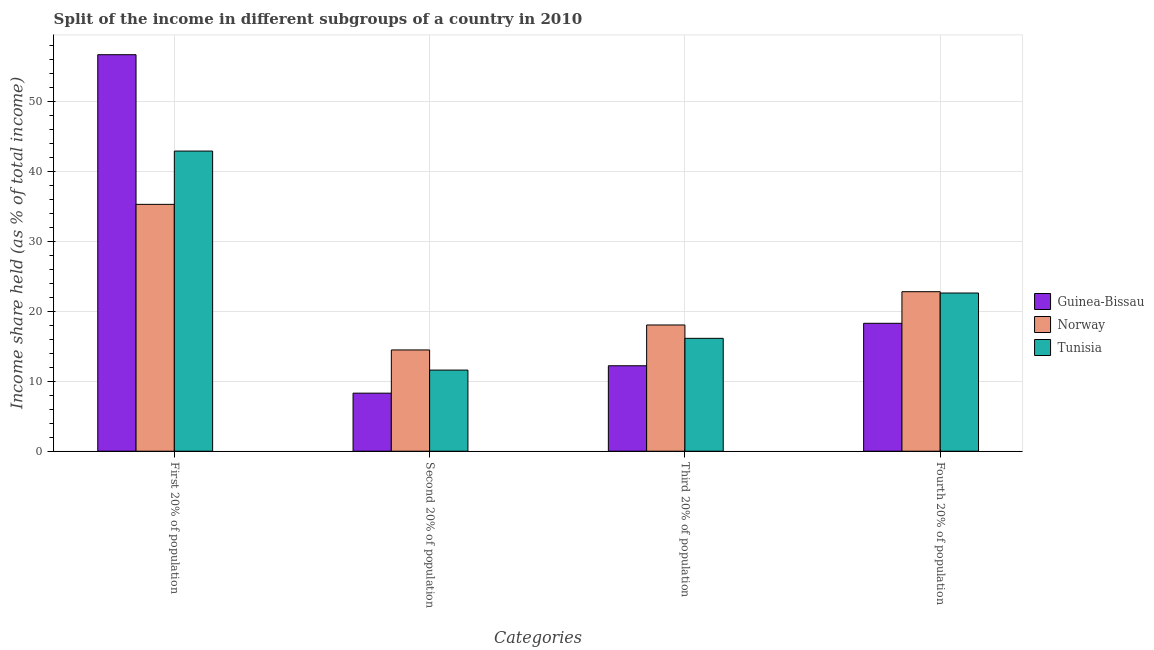Are the number of bars per tick equal to the number of legend labels?
Provide a succinct answer. Yes. How many bars are there on the 2nd tick from the left?
Offer a terse response. 3. What is the label of the 3rd group of bars from the left?
Provide a short and direct response. Third 20% of population. What is the share of the income held by fourth 20% of the population in Norway?
Ensure brevity in your answer.  22.81. Across all countries, what is the maximum share of the income held by second 20% of the population?
Make the answer very short. 14.48. Across all countries, what is the minimum share of the income held by second 20% of the population?
Ensure brevity in your answer.  8.3. In which country was the share of the income held by fourth 20% of the population minimum?
Your response must be concise. Guinea-Bissau. What is the total share of the income held by second 20% of the population in the graph?
Your response must be concise. 34.38. What is the difference between the share of the income held by fourth 20% of the population in Guinea-Bissau and that in Tunisia?
Make the answer very short. -4.33. What is the difference between the share of the income held by second 20% of the population in Guinea-Bissau and the share of the income held by first 20% of the population in Norway?
Keep it short and to the point. -27. What is the average share of the income held by second 20% of the population per country?
Ensure brevity in your answer.  11.46. What is the difference between the share of the income held by first 20% of the population and share of the income held by second 20% of the population in Guinea-Bissau?
Your answer should be very brief. 48.4. In how many countries, is the share of the income held by third 20% of the population greater than 20 %?
Give a very brief answer. 0. What is the ratio of the share of the income held by fourth 20% of the population in Norway to that in Guinea-Bissau?
Offer a very short reply. 1.25. Is the share of the income held by third 20% of the population in Norway less than that in Tunisia?
Ensure brevity in your answer.  No. What is the difference between the highest and the second highest share of the income held by fourth 20% of the population?
Your answer should be compact. 0.19. What is the difference between the highest and the lowest share of the income held by first 20% of the population?
Make the answer very short. 21.4. Is the sum of the share of the income held by second 20% of the population in Tunisia and Guinea-Bissau greater than the maximum share of the income held by fourth 20% of the population across all countries?
Make the answer very short. No. Is it the case that in every country, the sum of the share of the income held by fourth 20% of the population and share of the income held by second 20% of the population is greater than the sum of share of the income held by first 20% of the population and share of the income held by third 20% of the population?
Keep it short and to the point. No. What does the 2nd bar from the left in Second 20% of population represents?
Your answer should be compact. Norway. What does the 1st bar from the right in Third 20% of population represents?
Your answer should be very brief. Tunisia. Is it the case that in every country, the sum of the share of the income held by first 20% of the population and share of the income held by second 20% of the population is greater than the share of the income held by third 20% of the population?
Your answer should be very brief. Yes. How many countries are there in the graph?
Keep it short and to the point. 3. Does the graph contain grids?
Provide a short and direct response. Yes. Where does the legend appear in the graph?
Ensure brevity in your answer.  Center right. How are the legend labels stacked?
Your answer should be very brief. Vertical. What is the title of the graph?
Keep it short and to the point. Split of the income in different subgroups of a country in 2010. What is the label or title of the X-axis?
Your response must be concise. Categories. What is the label or title of the Y-axis?
Give a very brief answer. Income share held (as % of total income). What is the Income share held (as % of total income) of Guinea-Bissau in First 20% of population?
Offer a terse response. 56.7. What is the Income share held (as % of total income) of Norway in First 20% of population?
Provide a succinct answer. 35.3. What is the Income share held (as % of total income) of Tunisia in First 20% of population?
Your response must be concise. 42.92. What is the Income share held (as % of total income) of Norway in Second 20% of population?
Ensure brevity in your answer.  14.48. What is the Income share held (as % of total income) in Tunisia in Second 20% of population?
Your answer should be compact. 11.6. What is the Income share held (as % of total income) in Guinea-Bissau in Third 20% of population?
Keep it short and to the point. 12.22. What is the Income share held (as % of total income) of Norway in Third 20% of population?
Provide a succinct answer. 18.05. What is the Income share held (as % of total income) in Tunisia in Third 20% of population?
Offer a terse response. 16.14. What is the Income share held (as % of total income) of Guinea-Bissau in Fourth 20% of population?
Offer a terse response. 18.29. What is the Income share held (as % of total income) in Norway in Fourth 20% of population?
Keep it short and to the point. 22.81. What is the Income share held (as % of total income) in Tunisia in Fourth 20% of population?
Your answer should be very brief. 22.62. Across all Categories, what is the maximum Income share held (as % of total income) of Guinea-Bissau?
Offer a terse response. 56.7. Across all Categories, what is the maximum Income share held (as % of total income) of Norway?
Your response must be concise. 35.3. Across all Categories, what is the maximum Income share held (as % of total income) in Tunisia?
Keep it short and to the point. 42.92. Across all Categories, what is the minimum Income share held (as % of total income) of Guinea-Bissau?
Provide a succinct answer. 8.3. Across all Categories, what is the minimum Income share held (as % of total income) of Norway?
Your answer should be compact. 14.48. What is the total Income share held (as % of total income) of Guinea-Bissau in the graph?
Provide a succinct answer. 95.51. What is the total Income share held (as % of total income) in Norway in the graph?
Offer a very short reply. 90.64. What is the total Income share held (as % of total income) in Tunisia in the graph?
Offer a terse response. 93.28. What is the difference between the Income share held (as % of total income) in Guinea-Bissau in First 20% of population and that in Second 20% of population?
Make the answer very short. 48.4. What is the difference between the Income share held (as % of total income) in Norway in First 20% of population and that in Second 20% of population?
Offer a very short reply. 20.82. What is the difference between the Income share held (as % of total income) in Tunisia in First 20% of population and that in Second 20% of population?
Offer a terse response. 31.32. What is the difference between the Income share held (as % of total income) of Guinea-Bissau in First 20% of population and that in Third 20% of population?
Offer a very short reply. 44.48. What is the difference between the Income share held (as % of total income) in Norway in First 20% of population and that in Third 20% of population?
Your answer should be very brief. 17.25. What is the difference between the Income share held (as % of total income) in Tunisia in First 20% of population and that in Third 20% of population?
Your response must be concise. 26.78. What is the difference between the Income share held (as % of total income) in Guinea-Bissau in First 20% of population and that in Fourth 20% of population?
Provide a succinct answer. 38.41. What is the difference between the Income share held (as % of total income) of Norway in First 20% of population and that in Fourth 20% of population?
Your answer should be compact. 12.49. What is the difference between the Income share held (as % of total income) of Tunisia in First 20% of population and that in Fourth 20% of population?
Make the answer very short. 20.3. What is the difference between the Income share held (as % of total income) of Guinea-Bissau in Second 20% of population and that in Third 20% of population?
Provide a short and direct response. -3.92. What is the difference between the Income share held (as % of total income) in Norway in Second 20% of population and that in Third 20% of population?
Provide a succinct answer. -3.57. What is the difference between the Income share held (as % of total income) in Tunisia in Second 20% of population and that in Third 20% of population?
Offer a very short reply. -4.54. What is the difference between the Income share held (as % of total income) in Guinea-Bissau in Second 20% of population and that in Fourth 20% of population?
Your answer should be compact. -9.99. What is the difference between the Income share held (as % of total income) in Norway in Second 20% of population and that in Fourth 20% of population?
Provide a short and direct response. -8.33. What is the difference between the Income share held (as % of total income) of Tunisia in Second 20% of population and that in Fourth 20% of population?
Your answer should be compact. -11.02. What is the difference between the Income share held (as % of total income) in Guinea-Bissau in Third 20% of population and that in Fourth 20% of population?
Give a very brief answer. -6.07. What is the difference between the Income share held (as % of total income) of Norway in Third 20% of population and that in Fourth 20% of population?
Your response must be concise. -4.76. What is the difference between the Income share held (as % of total income) of Tunisia in Third 20% of population and that in Fourth 20% of population?
Your answer should be compact. -6.48. What is the difference between the Income share held (as % of total income) of Guinea-Bissau in First 20% of population and the Income share held (as % of total income) of Norway in Second 20% of population?
Keep it short and to the point. 42.22. What is the difference between the Income share held (as % of total income) of Guinea-Bissau in First 20% of population and the Income share held (as % of total income) of Tunisia in Second 20% of population?
Ensure brevity in your answer.  45.1. What is the difference between the Income share held (as % of total income) of Norway in First 20% of population and the Income share held (as % of total income) of Tunisia in Second 20% of population?
Keep it short and to the point. 23.7. What is the difference between the Income share held (as % of total income) of Guinea-Bissau in First 20% of population and the Income share held (as % of total income) of Norway in Third 20% of population?
Your answer should be very brief. 38.65. What is the difference between the Income share held (as % of total income) of Guinea-Bissau in First 20% of population and the Income share held (as % of total income) of Tunisia in Third 20% of population?
Your answer should be compact. 40.56. What is the difference between the Income share held (as % of total income) of Norway in First 20% of population and the Income share held (as % of total income) of Tunisia in Third 20% of population?
Make the answer very short. 19.16. What is the difference between the Income share held (as % of total income) of Guinea-Bissau in First 20% of population and the Income share held (as % of total income) of Norway in Fourth 20% of population?
Make the answer very short. 33.89. What is the difference between the Income share held (as % of total income) in Guinea-Bissau in First 20% of population and the Income share held (as % of total income) in Tunisia in Fourth 20% of population?
Your answer should be compact. 34.08. What is the difference between the Income share held (as % of total income) of Norway in First 20% of population and the Income share held (as % of total income) of Tunisia in Fourth 20% of population?
Offer a terse response. 12.68. What is the difference between the Income share held (as % of total income) of Guinea-Bissau in Second 20% of population and the Income share held (as % of total income) of Norway in Third 20% of population?
Your answer should be compact. -9.75. What is the difference between the Income share held (as % of total income) of Guinea-Bissau in Second 20% of population and the Income share held (as % of total income) of Tunisia in Third 20% of population?
Provide a short and direct response. -7.84. What is the difference between the Income share held (as % of total income) of Norway in Second 20% of population and the Income share held (as % of total income) of Tunisia in Third 20% of population?
Ensure brevity in your answer.  -1.66. What is the difference between the Income share held (as % of total income) in Guinea-Bissau in Second 20% of population and the Income share held (as % of total income) in Norway in Fourth 20% of population?
Offer a very short reply. -14.51. What is the difference between the Income share held (as % of total income) in Guinea-Bissau in Second 20% of population and the Income share held (as % of total income) in Tunisia in Fourth 20% of population?
Provide a short and direct response. -14.32. What is the difference between the Income share held (as % of total income) in Norway in Second 20% of population and the Income share held (as % of total income) in Tunisia in Fourth 20% of population?
Your answer should be compact. -8.14. What is the difference between the Income share held (as % of total income) of Guinea-Bissau in Third 20% of population and the Income share held (as % of total income) of Norway in Fourth 20% of population?
Provide a short and direct response. -10.59. What is the difference between the Income share held (as % of total income) of Guinea-Bissau in Third 20% of population and the Income share held (as % of total income) of Tunisia in Fourth 20% of population?
Provide a succinct answer. -10.4. What is the difference between the Income share held (as % of total income) in Norway in Third 20% of population and the Income share held (as % of total income) in Tunisia in Fourth 20% of population?
Offer a terse response. -4.57. What is the average Income share held (as % of total income) of Guinea-Bissau per Categories?
Your response must be concise. 23.88. What is the average Income share held (as % of total income) in Norway per Categories?
Make the answer very short. 22.66. What is the average Income share held (as % of total income) in Tunisia per Categories?
Your response must be concise. 23.32. What is the difference between the Income share held (as % of total income) of Guinea-Bissau and Income share held (as % of total income) of Norway in First 20% of population?
Keep it short and to the point. 21.4. What is the difference between the Income share held (as % of total income) in Guinea-Bissau and Income share held (as % of total income) in Tunisia in First 20% of population?
Your answer should be very brief. 13.78. What is the difference between the Income share held (as % of total income) in Norway and Income share held (as % of total income) in Tunisia in First 20% of population?
Offer a very short reply. -7.62. What is the difference between the Income share held (as % of total income) in Guinea-Bissau and Income share held (as % of total income) in Norway in Second 20% of population?
Make the answer very short. -6.18. What is the difference between the Income share held (as % of total income) of Norway and Income share held (as % of total income) of Tunisia in Second 20% of population?
Keep it short and to the point. 2.88. What is the difference between the Income share held (as % of total income) of Guinea-Bissau and Income share held (as % of total income) of Norway in Third 20% of population?
Offer a terse response. -5.83. What is the difference between the Income share held (as % of total income) in Guinea-Bissau and Income share held (as % of total income) in Tunisia in Third 20% of population?
Your response must be concise. -3.92. What is the difference between the Income share held (as % of total income) of Norway and Income share held (as % of total income) of Tunisia in Third 20% of population?
Your response must be concise. 1.91. What is the difference between the Income share held (as % of total income) of Guinea-Bissau and Income share held (as % of total income) of Norway in Fourth 20% of population?
Your response must be concise. -4.52. What is the difference between the Income share held (as % of total income) of Guinea-Bissau and Income share held (as % of total income) of Tunisia in Fourth 20% of population?
Offer a very short reply. -4.33. What is the difference between the Income share held (as % of total income) of Norway and Income share held (as % of total income) of Tunisia in Fourth 20% of population?
Provide a succinct answer. 0.19. What is the ratio of the Income share held (as % of total income) of Guinea-Bissau in First 20% of population to that in Second 20% of population?
Offer a very short reply. 6.83. What is the ratio of the Income share held (as % of total income) in Norway in First 20% of population to that in Second 20% of population?
Provide a succinct answer. 2.44. What is the ratio of the Income share held (as % of total income) of Tunisia in First 20% of population to that in Second 20% of population?
Provide a succinct answer. 3.7. What is the ratio of the Income share held (as % of total income) in Guinea-Bissau in First 20% of population to that in Third 20% of population?
Provide a succinct answer. 4.64. What is the ratio of the Income share held (as % of total income) of Norway in First 20% of population to that in Third 20% of population?
Your answer should be very brief. 1.96. What is the ratio of the Income share held (as % of total income) in Tunisia in First 20% of population to that in Third 20% of population?
Ensure brevity in your answer.  2.66. What is the ratio of the Income share held (as % of total income) in Guinea-Bissau in First 20% of population to that in Fourth 20% of population?
Give a very brief answer. 3.1. What is the ratio of the Income share held (as % of total income) of Norway in First 20% of population to that in Fourth 20% of population?
Your answer should be very brief. 1.55. What is the ratio of the Income share held (as % of total income) in Tunisia in First 20% of population to that in Fourth 20% of population?
Your answer should be very brief. 1.9. What is the ratio of the Income share held (as % of total income) of Guinea-Bissau in Second 20% of population to that in Third 20% of population?
Provide a succinct answer. 0.68. What is the ratio of the Income share held (as % of total income) in Norway in Second 20% of population to that in Third 20% of population?
Provide a short and direct response. 0.8. What is the ratio of the Income share held (as % of total income) in Tunisia in Second 20% of population to that in Third 20% of population?
Keep it short and to the point. 0.72. What is the ratio of the Income share held (as % of total income) in Guinea-Bissau in Second 20% of population to that in Fourth 20% of population?
Provide a short and direct response. 0.45. What is the ratio of the Income share held (as % of total income) of Norway in Second 20% of population to that in Fourth 20% of population?
Provide a succinct answer. 0.63. What is the ratio of the Income share held (as % of total income) of Tunisia in Second 20% of population to that in Fourth 20% of population?
Keep it short and to the point. 0.51. What is the ratio of the Income share held (as % of total income) of Guinea-Bissau in Third 20% of population to that in Fourth 20% of population?
Your response must be concise. 0.67. What is the ratio of the Income share held (as % of total income) of Norway in Third 20% of population to that in Fourth 20% of population?
Provide a succinct answer. 0.79. What is the ratio of the Income share held (as % of total income) of Tunisia in Third 20% of population to that in Fourth 20% of population?
Make the answer very short. 0.71. What is the difference between the highest and the second highest Income share held (as % of total income) in Guinea-Bissau?
Offer a very short reply. 38.41. What is the difference between the highest and the second highest Income share held (as % of total income) of Norway?
Make the answer very short. 12.49. What is the difference between the highest and the second highest Income share held (as % of total income) of Tunisia?
Provide a short and direct response. 20.3. What is the difference between the highest and the lowest Income share held (as % of total income) of Guinea-Bissau?
Your answer should be compact. 48.4. What is the difference between the highest and the lowest Income share held (as % of total income) in Norway?
Offer a terse response. 20.82. What is the difference between the highest and the lowest Income share held (as % of total income) in Tunisia?
Provide a succinct answer. 31.32. 